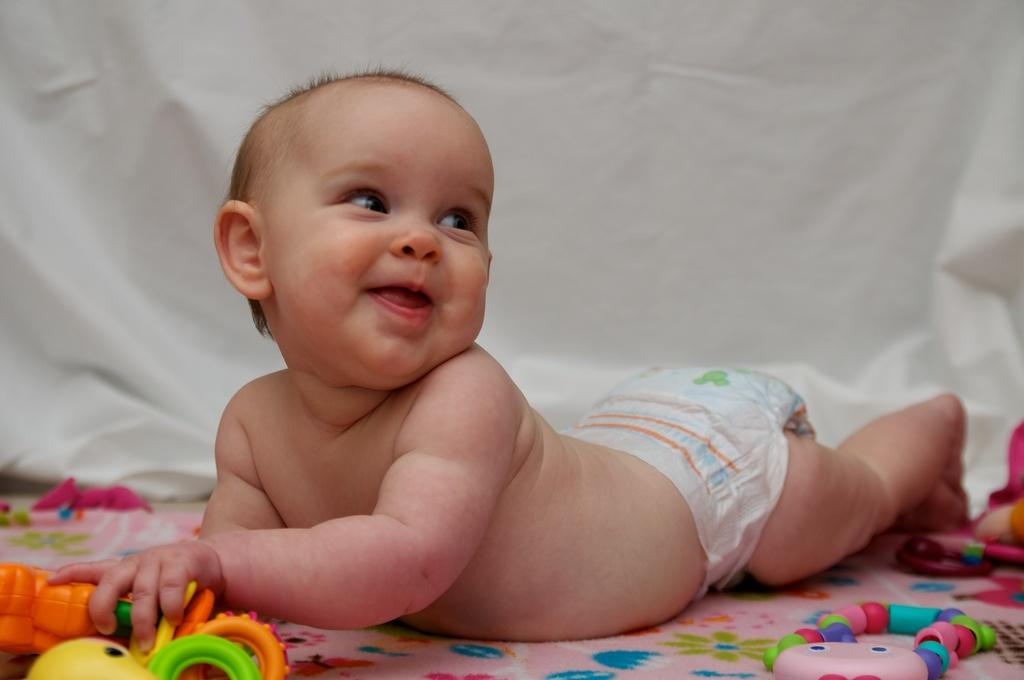What is the main subject of the image? The main subject of the image is a baby. What is the baby doing in the image? The baby is laying on a bed-sheet and holding toys in their hand. What is the baby's facial expression in the image? The baby is smiling in the image. What direction is the baby looking in the image? The baby is looking to the right side in the image. What color cloth can be seen in the background of the image? There is a white color cloth in the background of the image. How many girls are present in the image? There are no girls present in the image; it features a baby. What type of education is the baby receiving in the image? There is no indication of education in the image; it simply shows a baby holding toys and smiling. 